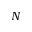Convert formula to latex. <formula><loc_0><loc_0><loc_500><loc_500>N</formula> 